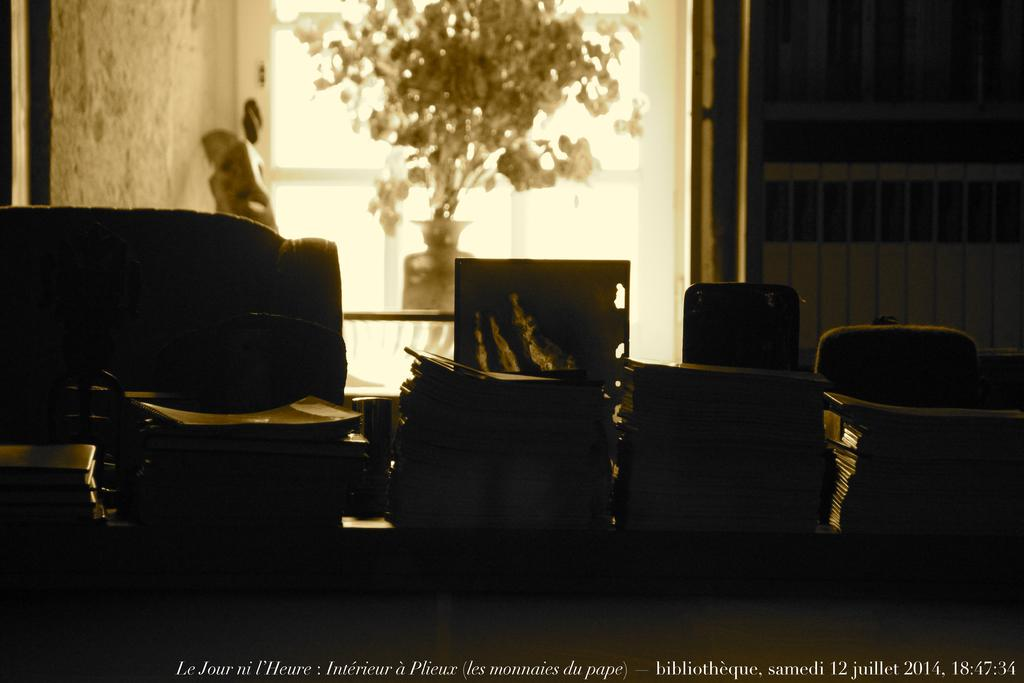What is on the table in the image? There are objects on the table in the image. What type of furniture is present in the image? There are chairs in the image. What can be seen in the background of the image? There is a plant in a pot and a rail visible in the background of the image. What thrilling activity is happening on the rail in the image? There is no indication of any thrilling activity happening on the rail in the image; it is simply a visible background element. Can you see a train passing by on the rail in the image? There is no train visible on the rail in the image. 